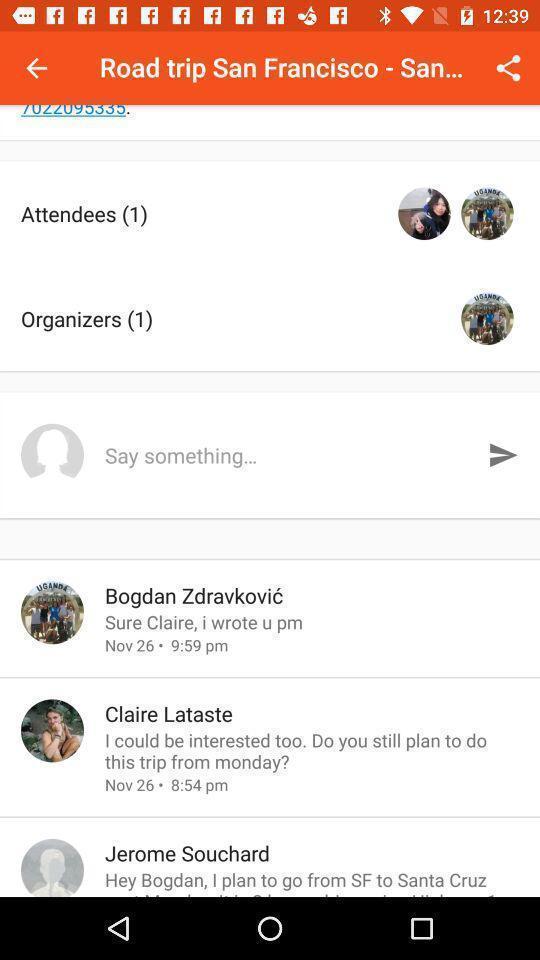Summarize the information in this screenshot. Page displays comments in app. 